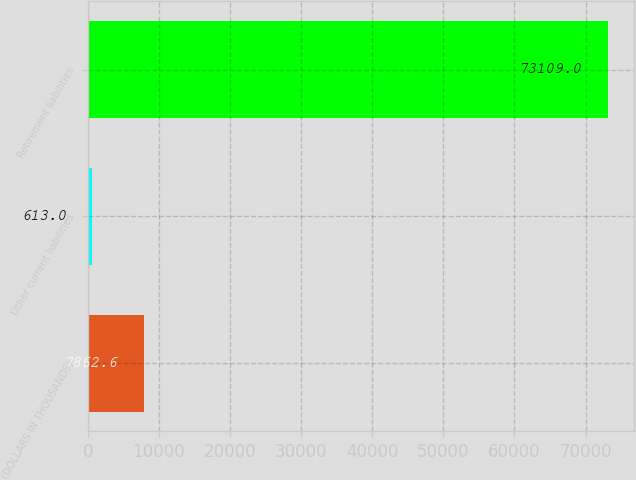<chart> <loc_0><loc_0><loc_500><loc_500><bar_chart><fcel>(DOLLARS IN THOUSANDS)<fcel>Other current liabilities<fcel>Retirement liabilities<nl><fcel>7862.6<fcel>613<fcel>73109<nl></chart> 